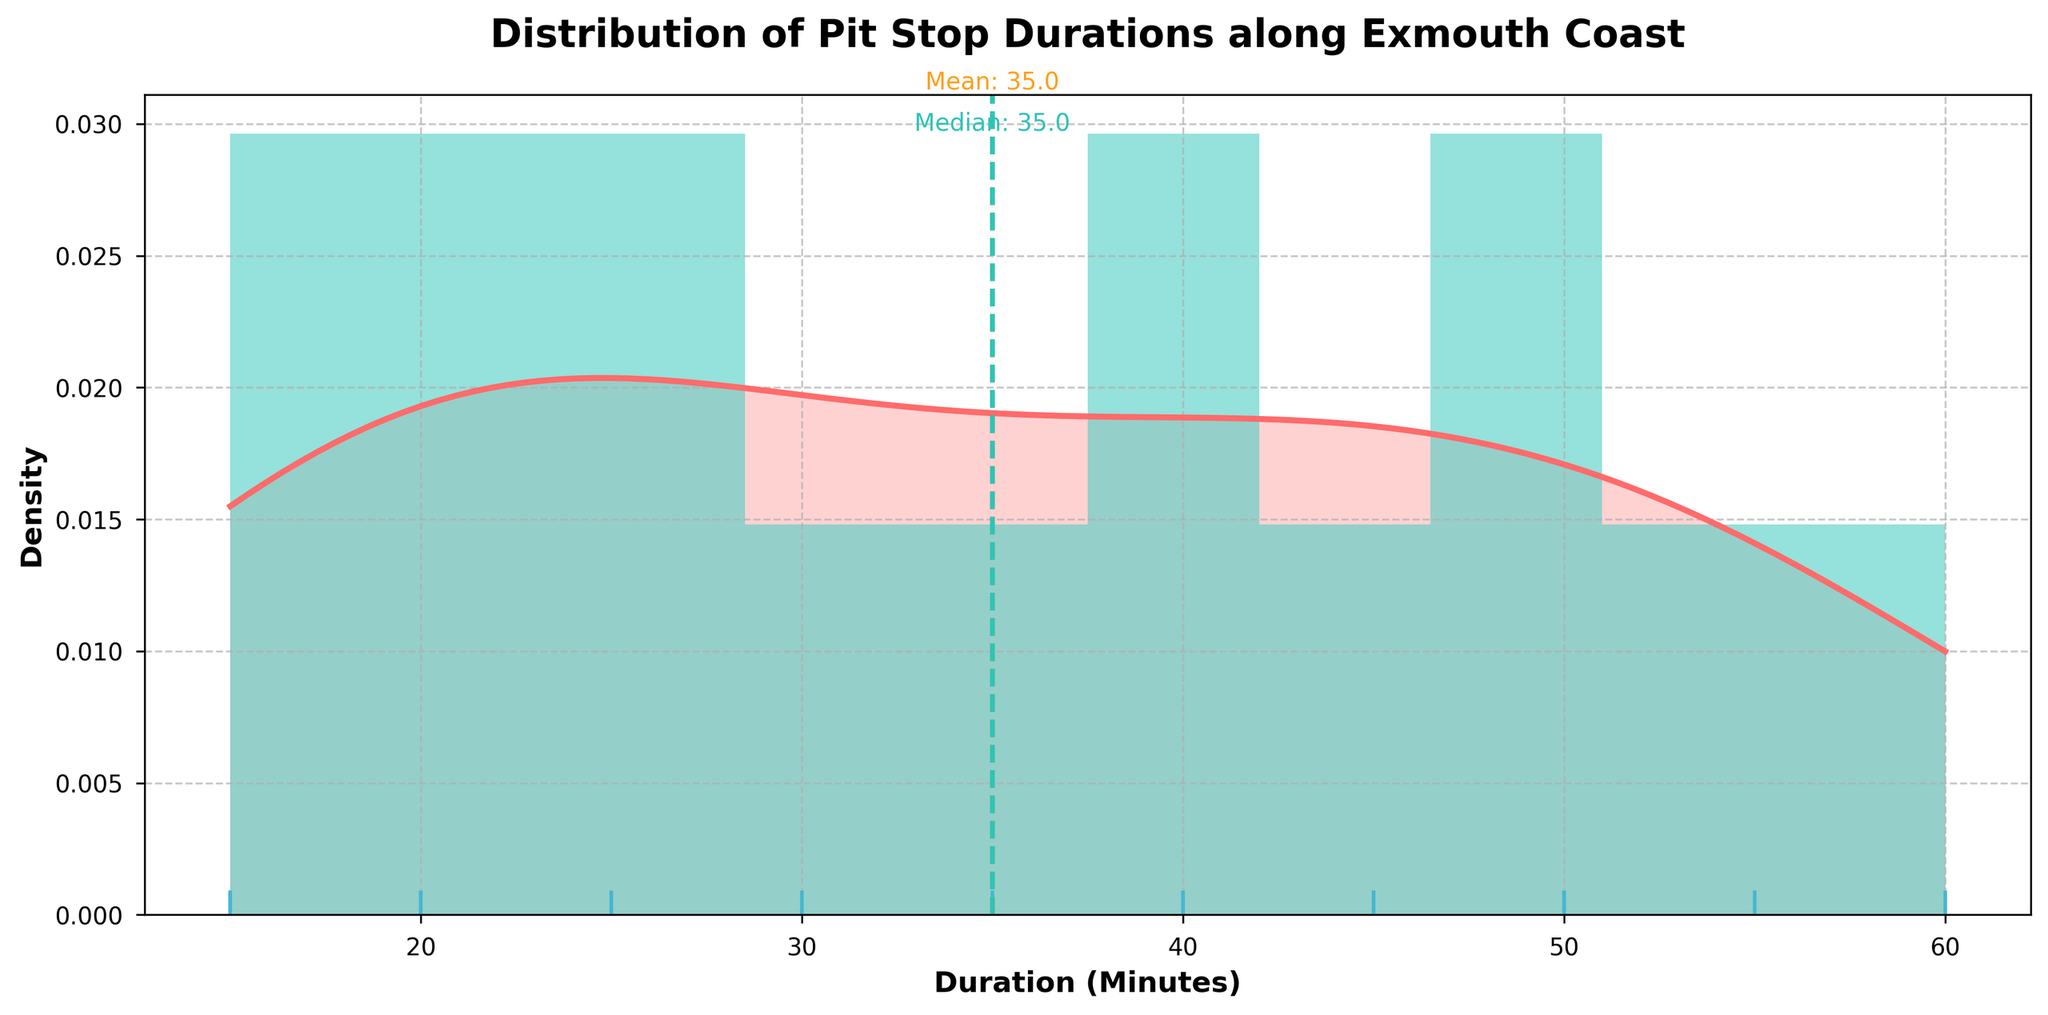What is the title of the plot? The title of the plot is displayed at the top and reads: "Distribution of Pit Stop Durations along Exmouth Coast".
Answer: Distribution of Pit Stop Durations along Exmouth Coast What time duration has the highest density for pit stops? To find the time duration with the highest density, look at the peak of the KDE (line plot). The highest density occurs around the 40-minute mark.
Answer: 40 minutes How many pit stop durations fall within the 20-minute range on the x-axis? To determine the number of pit stop durations in the 20-minute range, look at the histogram bars. There are 2 bars in the 20-minute range.
Answer: 2 Which is greater, the mean or median duration of pit stops? To compare the mean and median, look at the vertical lines annotating each. The mean duration line (yellow) is slightly to the right of the median line (teal), hence the mean is greater.
Answer: Mean What is the approximate value of the mean duration? The mean duration is marked by a vertical yellow dashed line. The mean value is annotated above the line and is around 32 minutes.
Answer: 32 minutes What is the approximate value of the median duration? The median duration is marked by a vertical teal dashed line. The median value is annotated above the line and is around 30 minutes.
Answer: 30 minutes How many pit stop locations have durations above 40 minutes? To find the number of durations above 40 minutes, look at the rug plot (markers on the x-axis). Count the markers right of the 40-minute mark; there are 5 such markers.
Answer: 5 In which duration range does the histogram have the maximum frequency? The histogram has the highest bar at the 40-50 minute range, showing the maximum frequency of pit stops within this range.
Answer: 40-50 minutes What is the color of the histogram bars? The histogram bars are shaded in a light teal color, distinct from the KDE plot's crimson hue.
Answer: Light teal Is there more variability in durations above or below the median? To determine variability, observe the spread of the rug plot markers and the KDE plot above and below the median. Clearly, durations above the median show a wider range and are more spread out, indicating more variability.
Answer: Above the median 